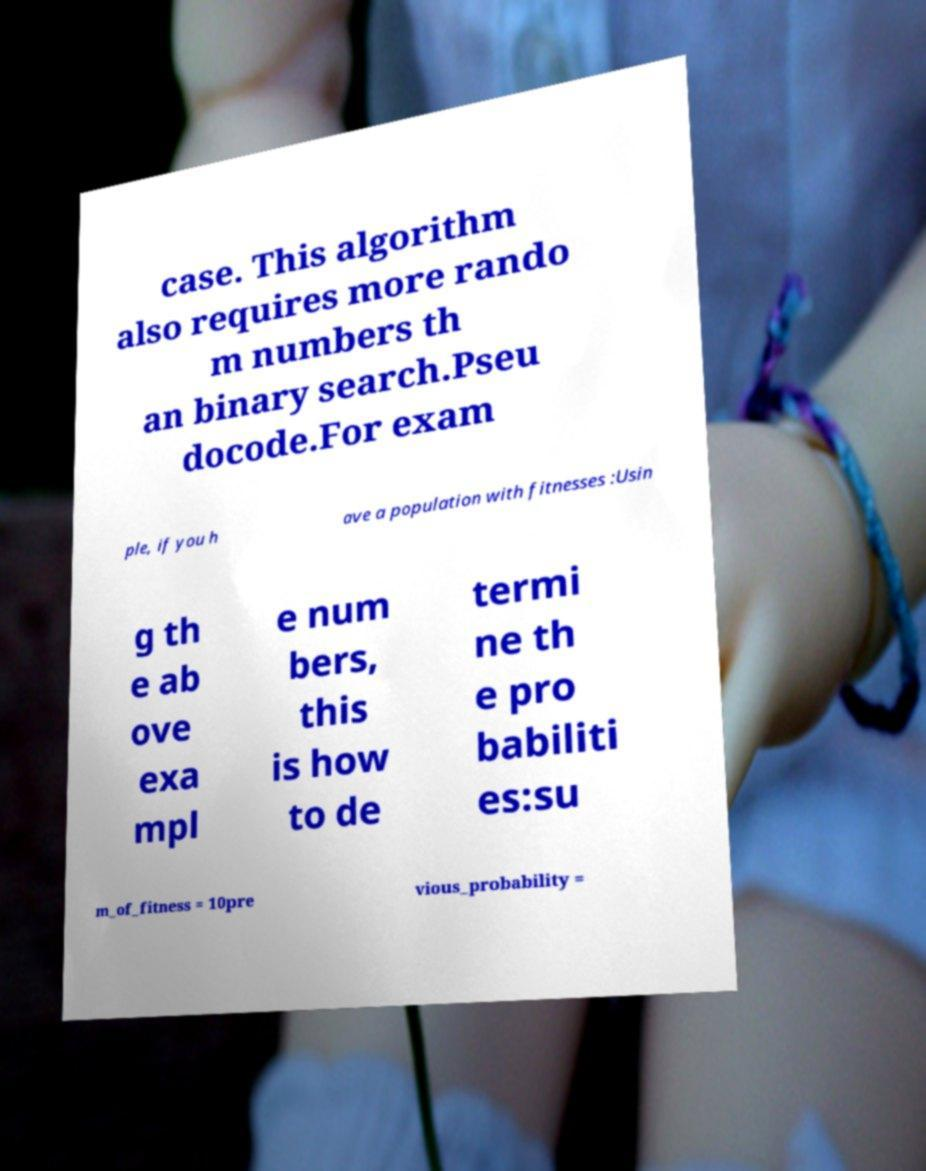Please identify and transcribe the text found in this image. case. This algorithm also requires more rando m numbers th an binary search.Pseu docode.For exam ple, if you h ave a population with fitnesses :Usin g th e ab ove exa mpl e num bers, this is how to de termi ne th e pro babiliti es:su m_of_fitness = 10pre vious_probability = 